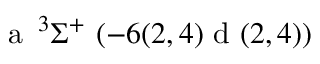<formula> <loc_0><loc_0><loc_500><loc_500>a \, ^ { 3 } \Sigma ^ { + } ( - 6 ( 2 , 4 ) d ( 2 , 4 ) )</formula> 